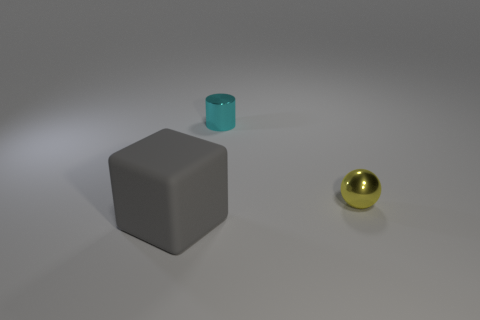What might be the use of these objects? The grey cube could serve various purposes, potentially as a weight or a paperweight due to its size and shape. The small green metallic cylinder could be part of some mechanical device or could be a container for something small. The golden sphere might be purely decorative or could be a precision ball used in machinery.  Are these objects typically found together? These objects are not typically found together in every day contexts. They seem unrelated and each might belong to different environments: the grey cube perhaps in an office, the green cylinder in a workshop, and the gold sphere as part of a decorative set or perhaps in an industrial setting depending on its material. 